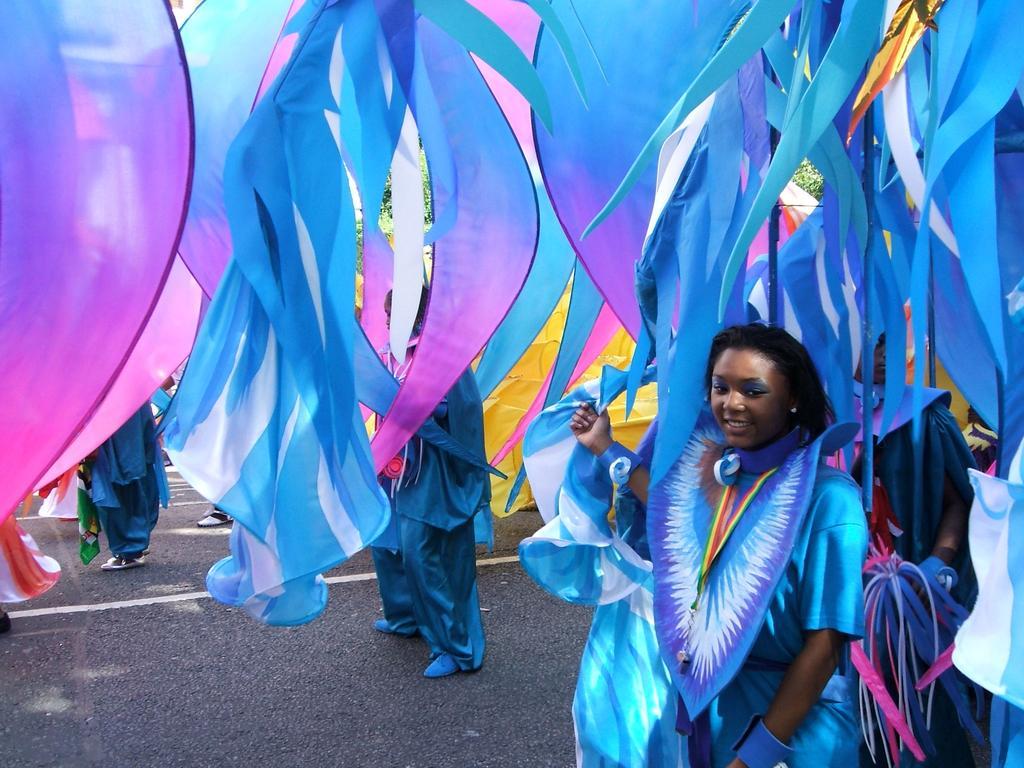Please provide a concise description of this image. In this image, we can see people wearing costumes and in the background, there are streamers. At the bottom, there is a road. 